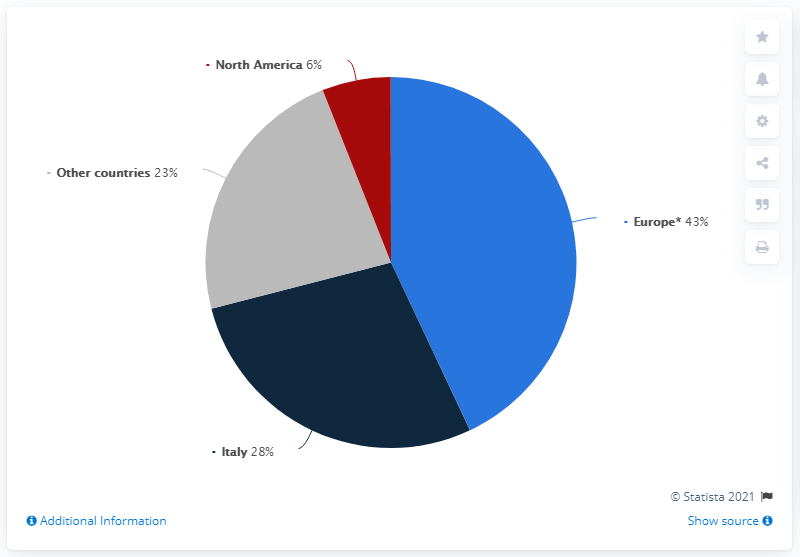Point out several critical features in this image. The total revenue share of countries with a revenue below 30% minus the revenue share of Europe equals 14. The largest segment of the pie chart represents 0.43 of the whole pie chart. 